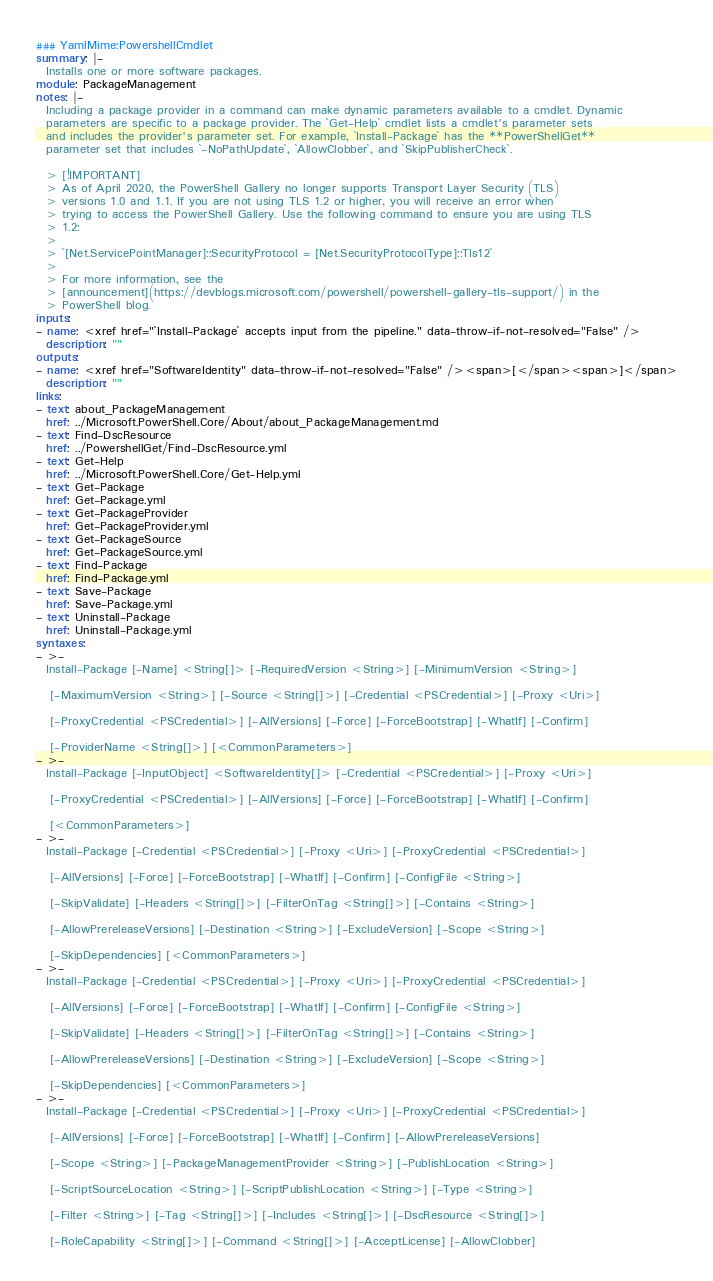Convert code to text. <code><loc_0><loc_0><loc_500><loc_500><_YAML_>### YamlMime:PowershellCmdlet
summary: |-
  Installs one or more software packages.
module: PackageManagement
notes: |-
  Including a package provider in a command can make dynamic parameters available to a cmdlet. Dynamic
  parameters are specific to a package provider. The `Get-Help` cmdlet lists a cmdlet's parameter sets
  and includes the provider's parameter set. For example, `Install-Package` has the **PowerShellGet**
  parameter set that includes `-NoPathUpdate`, `AllowClobber`, and `SkipPublisherCheck`.

  > [!IMPORTANT]
  > As of April 2020, the PowerShell Gallery no longer supports Transport Layer Security (TLS)
  > versions 1.0 and 1.1. If you are not using TLS 1.2 or higher, you will receive an error when
  > trying to access the PowerShell Gallery. Use the following command to ensure you are using TLS
  > 1.2:
  >
  > `[Net.ServicePointManager]::SecurityProtocol = [Net.SecurityProtocolType]::Tls12`
  >
  > For more information, see the
  > [announcement](https://devblogs.microsoft.com/powershell/powershell-gallery-tls-support/) in the
  > PowerShell blog.
inputs:
- name: <xref href="`Install-Package` accepts input from the pipeline." data-throw-if-not-resolved="False" />
  description: ""
outputs:
- name: <xref href="SoftwareIdentity" data-throw-if-not-resolved="False" /><span>[</span><span>]</span>
  description: ""
links:
- text: about_PackageManagement
  href: ../Microsoft.PowerShell.Core/About/about_PackageManagement.md
- text: Find-DscResource
  href: ../PowershellGet/Find-DscResource.yml
- text: Get-Help
  href: ../Microsoft.PowerShell.Core/Get-Help.yml
- text: Get-Package
  href: Get-Package.yml
- text: Get-PackageProvider
  href: Get-PackageProvider.yml
- text: Get-PackageSource
  href: Get-PackageSource.yml
- text: Find-Package
  href: Find-Package.yml
- text: Save-Package
  href: Save-Package.yml
- text: Uninstall-Package
  href: Uninstall-Package.yml
syntaxes:
- >-
  Install-Package [-Name] <String[]> [-RequiredVersion <String>] [-MinimumVersion <String>]

   [-MaximumVersion <String>] [-Source <String[]>] [-Credential <PSCredential>] [-Proxy <Uri>]

   [-ProxyCredential <PSCredential>] [-AllVersions] [-Force] [-ForceBootstrap] [-WhatIf] [-Confirm]

   [-ProviderName <String[]>] [<CommonParameters>]
- >-
  Install-Package [-InputObject] <SoftwareIdentity[]> [-Credential <PSCredential>] [-Proxy <Uri>]

   [-ProxyCredential <PSCredential>] [-AllVersions] [-Force] [-ForceBootstrap] [-WhatIf] [-Confirm]

   [<CommonParameters>]
- >-
  Install-Package [-Credential <PSCredential>] [-Proxy <Uri>] [-ProxyCredential <PSCredential>]

   [-AllVersions] [-Force] [-ForceBootstrap] [-WhatIf] [-Confirm] [-ConfigFile <String>]

   [-SkipValidate] [-Headers <String[]>] [-FilterOnTag <String[]>] [-Contains <String>]

   [-AllowPrereleaseVersions] [-Destination <String>] [-ExcludeVersion] [-Scope <String>]

   [-SkipDependencies] [<CommonParameters>]
- >-
  Install-Package [-Credential <PSCredential>] [-Proxy <Uri>] [-ProxyCredential <PSCredential>]

   [-AllVersions] [-Force] [-ForceBootstrap] [-WhatIf] [-Confirm] [-ConfigFile <String>]

   [-SkipValidate] [-Headers <String[]>] [-FilterOnTag <String[]>] [-Contains <String>]

   [-AllowPrereleaseVersions] [-Destination <String>] [-ExcludeVersion] [-Scope <String>]

   [-SkipDependencies] [<CommonParameters>]
- >-
  Install-Package [-Credential <PSCredential>] [-Proxy <Uri>] [-ProxyCredential <PSCredential>]

   [-AllVersions] [-Force] [-ForceBootstrap] [-WhatIf] [-Confirm] [-AllowPrereleaseVersions]

   [-Scope <String>] [-PackageManagementProvider <String>] [-PublishLocation <String>]

   [-ScriptSourceLocation <String>] [-ScriptPublishLocation <String>] [-Type <String>]

   [-Filter <String>] [-Tag <String[]>] [-Includes <String[]>] [-DscResource <String[]>]

   [-RoleCapability <String[]>] [-Command <String[]>] [-AcceptLicense] [-AllowClobber]
</code> 